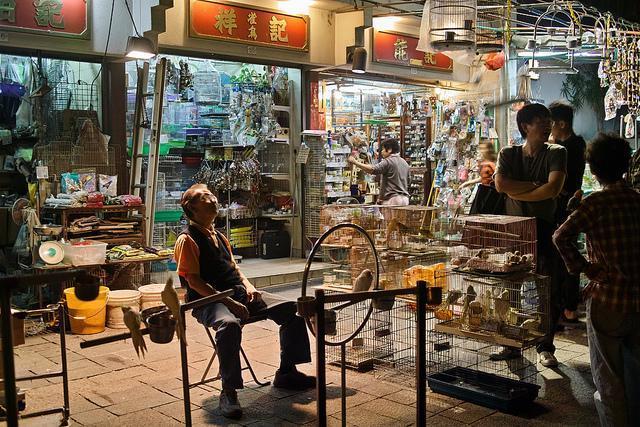How many people are there?
Give a very brief answer. 4. 